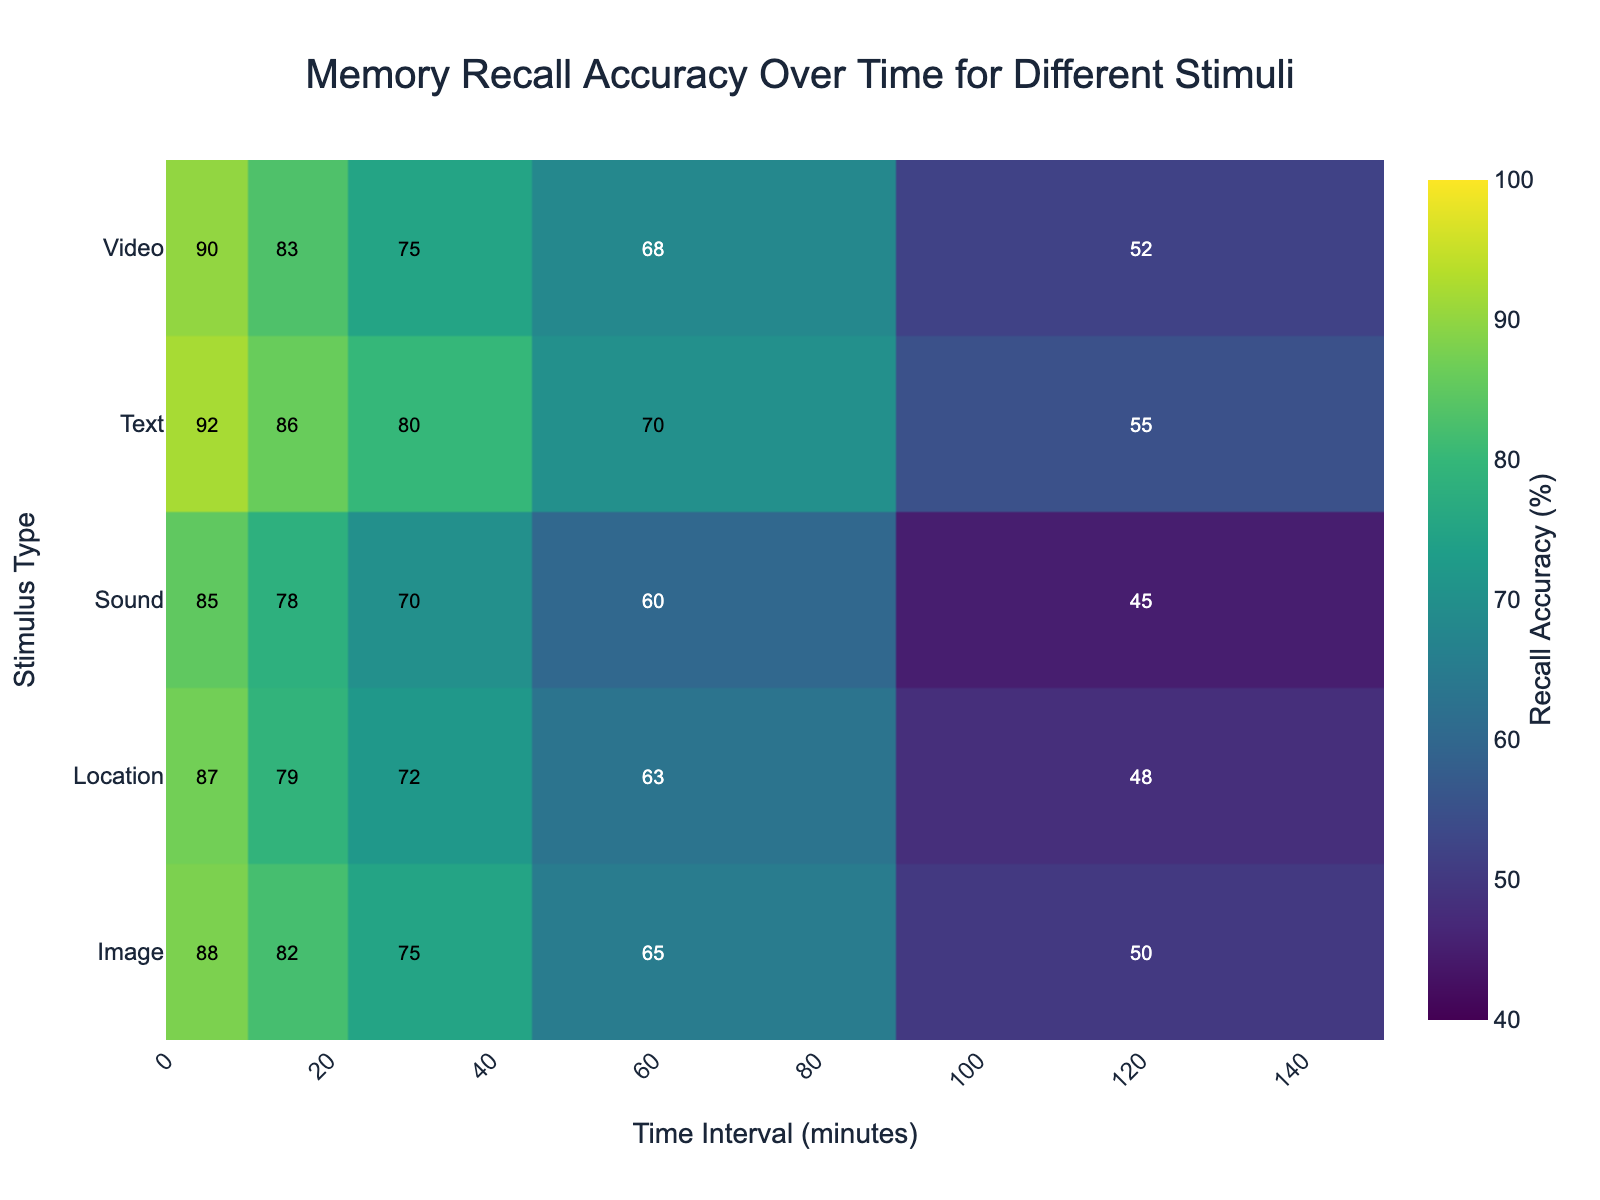What's the title of the heatmap? The title is usually displayed at the top of the figure. In this heatmap, it reads "Memory Recall Accuracy Over Time for Different Stimuli".
Answer: Memory Recall Accuracy Over Time for Different Stimuli What does the color scale represent in the heatmap? Color scales in heatmaps typically represent the magnitude of values. In this heatmap, the color scale is labeled with "Recall Accuracy (%)", indicating it represents memory recall accuracy percentages.
Answer: Recall Accuracy (%) Which stimulus type has the highest recall accuracy at the 5-minute interval? Look for the highest value in the 5-minute interval column. For the 5-minute interval, Text has the highest recall accuracy at 92%.
Answer: Text What is the recall accuracy of Sound after 30 minutes? Locate the intersection of the Sound row and the 30-minute interval column. The value is 70%.
Answer: 70% How does the recall accuracy for Video change from 5 to 120 minutes? Look at the values across the Video row from the 5-minute to the 120-minute interval: 90%, 83%, 75%, 68%, 52%. The accuracy decreases over time.
Answer: Decreases Which stimulus type shows the least decline in recall accuracy from 5 to 120 minutes? Calculate the difference between the 5-minute and 120-minute intervals for each stimulus type. Text shows the least decline: 92% - 55% = 37%.
Answer: Text Compare the recall accuracy of Image and Sound at the 60-minute interval. Which one is higher? Compare the values for Image and Sound at 60 minutes. Image is 65% and Sound is 60%. Thus, Image has higher recall accuracy.
Answer: Image What is the average recall accuracy of all types of stimuli at the 30-minute interval? Sum the values at the 30-minute interval and divide by the number of stimuli: (75 + 70 + 80 + 75 + 72)/5 = 74.4%.
Answer: 74.4% Which stimulus type has the lowest recall accuracy at the 120-minute interval, and what is its value? Identify the lowest value in the 120-minute interval column. Sound has the lowest recall accuracy at 45%.
Answer: Sound, 45% Which interval shows the highest variability in recall accuracy across different stimuli? Determine the range (max - min) for each interval column. The 120-minute interval has the highest variability: 55% (Text) - 45% (Sound) = 45%.
Answer: 120-minute interval 